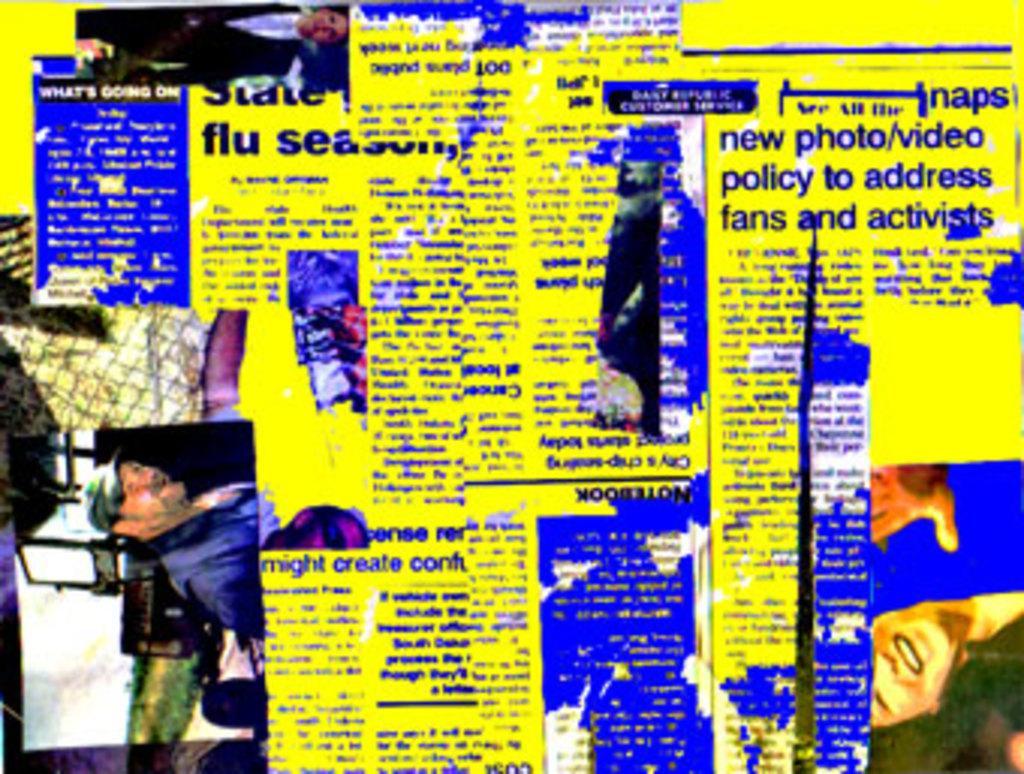Can you describe this image briefly? In this picture I can observe some text. On the left side I can observe two members. The background is in yellow color. 